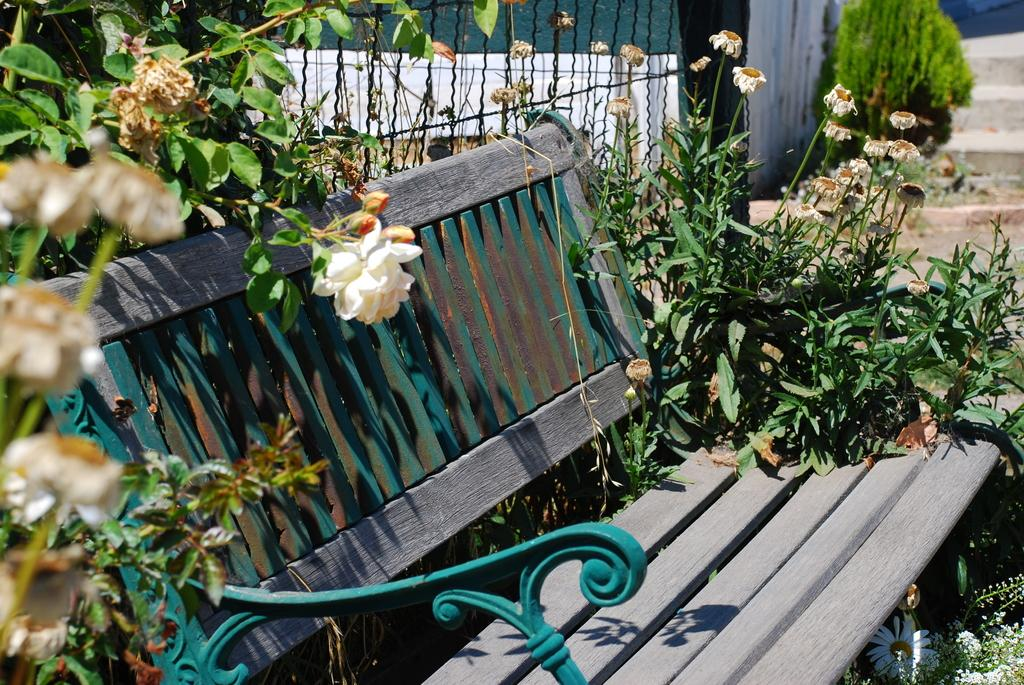What is the main object in the center of the image? There is a bench in the center of the image. What type of vegetation is present around the bench? There are plants and flowers around the bench. What architectural feature can be seen in the background of the image? There is a staircase in the background of the image. What type of pollution is visible in the image? There is no visible pollution in the image; it features a bench surrounded by plants and flowers, with a staircase in the background. 